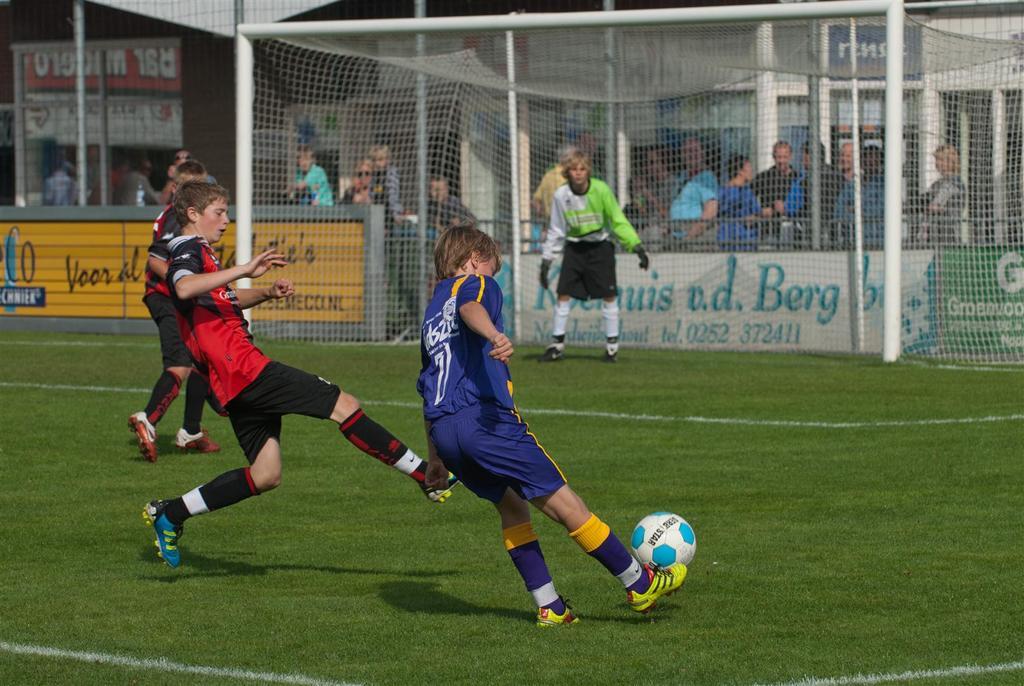What is the phone of the advertiser behind the goalie?
Keep it short and to the point. 0252 372411. What player is shooting?
Offer a terse response. 7. 